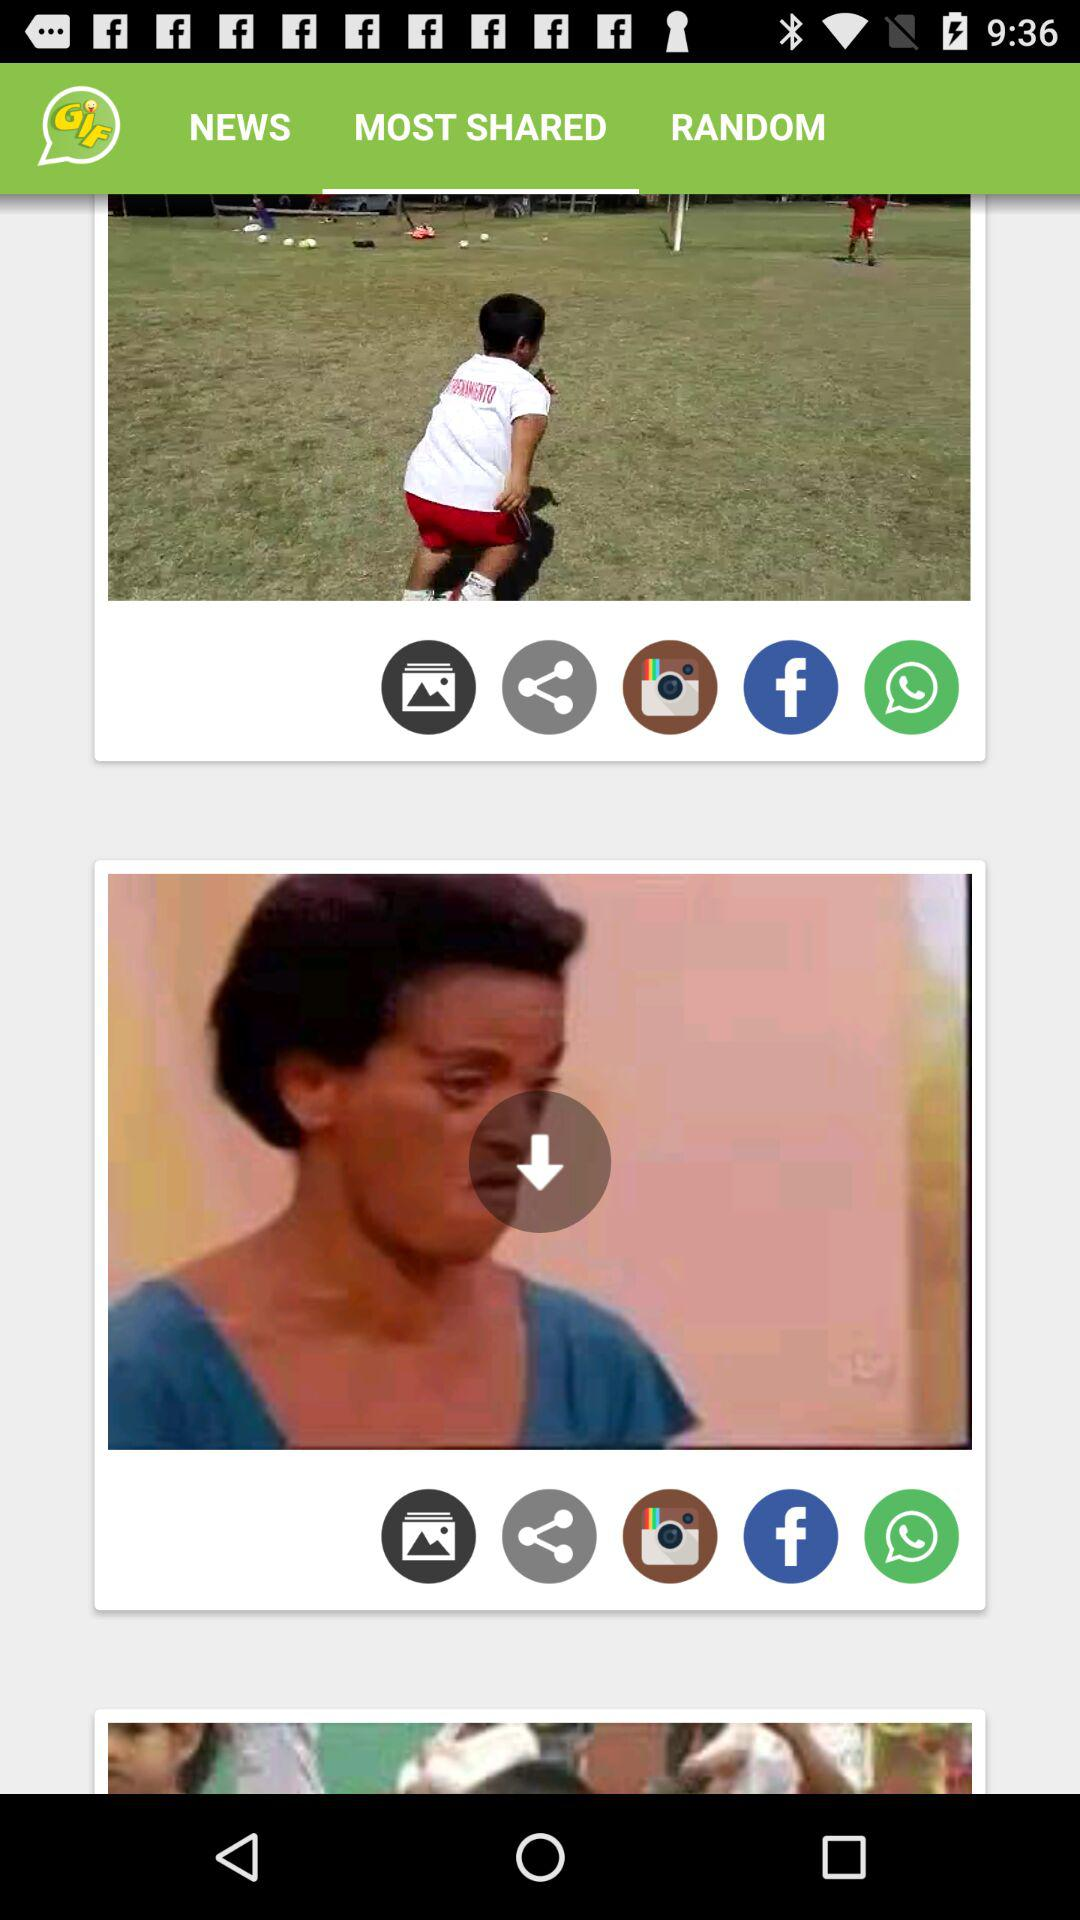Which tab is selected? The selected tab is "MOST SHARED". 